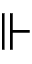<formula> <loc_0><loc_0><loc_500><loc_500>\ V d a s h</formula> 